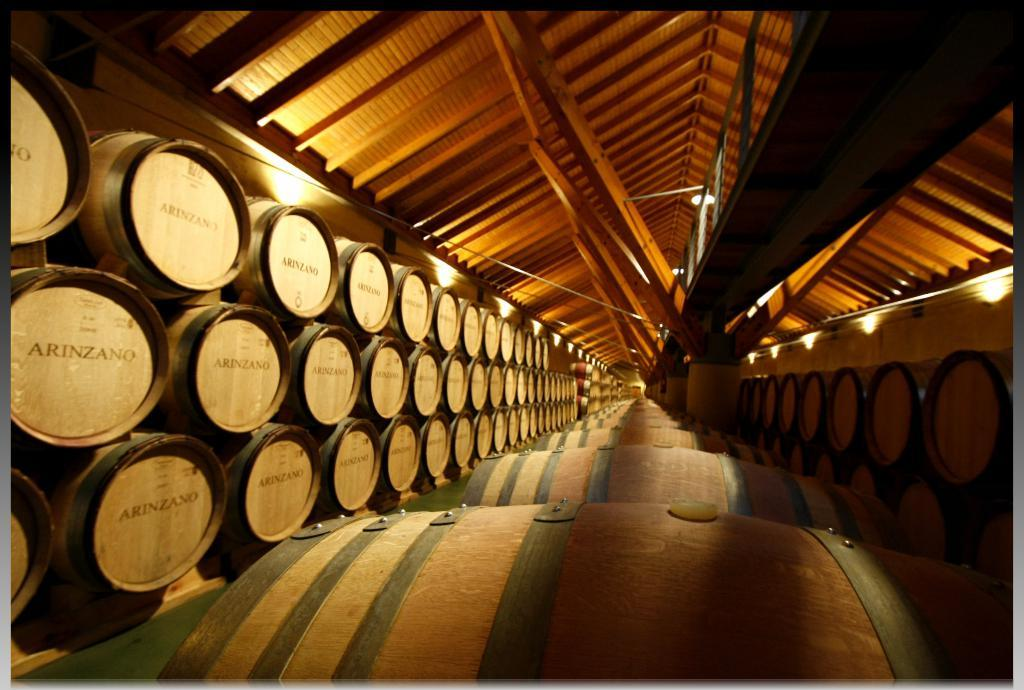<image>
Write a terse but informative summary of the picture. Arinzano wine barrels are stacked on top of each other along a long and narrow room. 